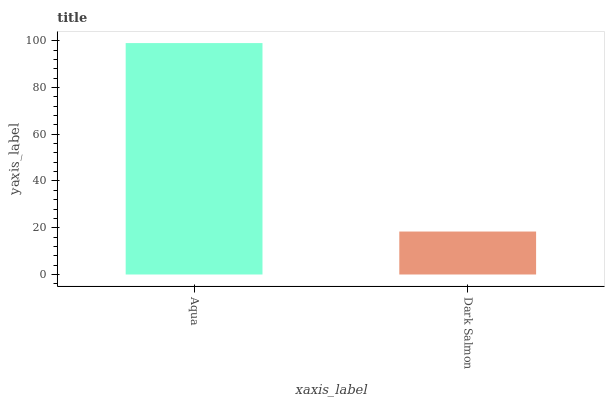Is Dark Salmon the maximum?
Answer yes or no. No. Is Aqua greater than Dark Salmon?
Answer yes or no. Yes. Is Dark Salmon less than Aqua?
Answer yes or no. Yes. Is Dark Salmon greater than Aqua?
Answer yes or no. No. Is Aqua less than Dark Salmon?
Answer yes or no. No. Is Aqua the high median?
Answer yes or no. Yes. Is Dark Salmon the low median?
Answer yes or no. Yes. Is Dark Salmon the high median?
Answer yes or no. No. Is Aqua the low median?
Answer yes or no. No. 